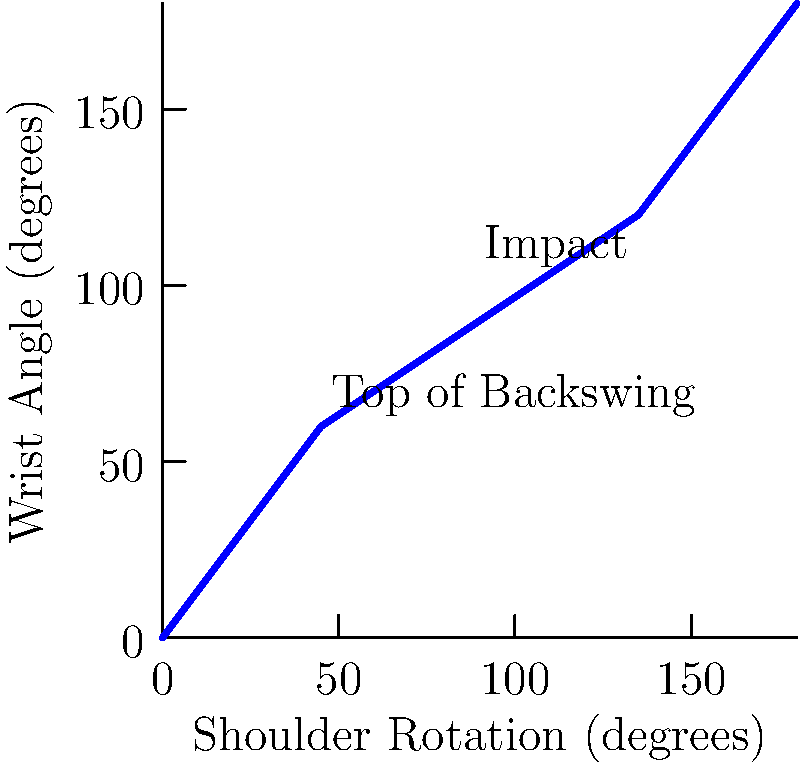Based on the graph showing the relationship between shoulder rotation and wrist angle during a golf swing, what is the approximate wrist angle at impact, and how does this biomechanical data support the importance of maintaining a firm wrist position for consistency and power in the golf swing? To answer this question, let's analyze the graph step-by-step:

1. The x-axis represents shoulder rotation in degrees, while the y-axis shows the wrist angle in degrees.

2. The graph depicts the relationship between these two variables during a golf swing.

3. We can see that the swing progresses from left to right, with the top of the backswing occurring at approximately 45 degrees of shoulder rotation.

4. The impact position is labeled on the graph at about 135 degrees of shoulder rotation.

5. To find the wrist angle at impact, we need to locate the y-value corresponding to 135 degrees on the x-axis.

6. From the graph, we can estimate that the wrist angle at impact is approximately 120 degrees.

7. This data supports the importance of maintaining a firm wrist position for consistency and power in the golf swing because:
   a) The wrist angle increases gradually throughout the swing, indicating a controlled release of the wrists.
   b) At impact, the wrist angle is still less than fully extended (180 degrees), suggesting that the golfer maintains some wrist cock for power.
   c) The consistent curve shows a smooth transition from backswing to impact, which is crucial for timing and consistency.

8. From a conservative perspective, this biomechanical data provides objective evidence for proper swing mechanics, which can be valuable in teaching and improving golf performance without relying on subjective opinions.
Answer: Wrist angle at impact: approximately 120 degrees. Data supports firm wrist position by showing controlled wrist release and maintenance of wrist cock at impact for power and consistency. 